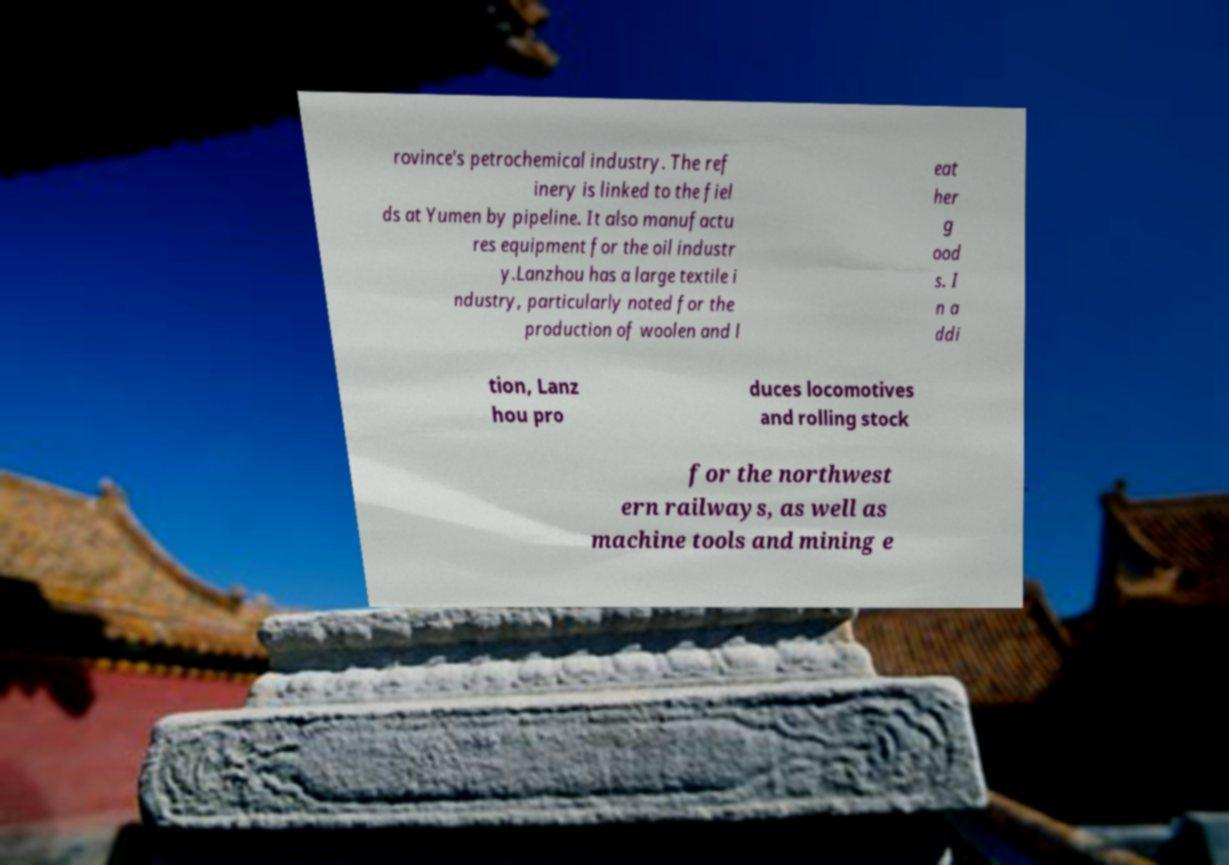Could you assist in decoding the text presented in this image and type it out clearly? rovince's petrochemical industry. The ref inery is linked to the fiel ds at Yumen by pipeline. It also manufactu res equipment for the oil industr y.Lanzhou has a large textile i ndustry, particularly noted for the production of woolen and l eat her g ood s. I n a ddi tion, Lanz hou pro duces locomotives and rolling stock for the northwest ern railways, as well as machine tools and mining e 